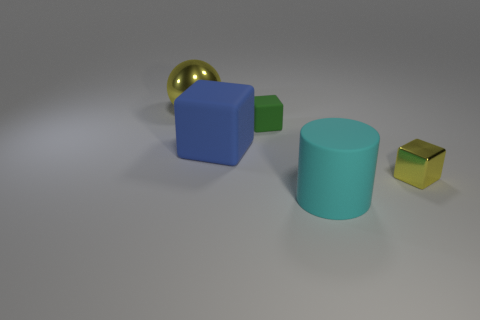Is the color of the large matte cylinder the same as the shiny object that is in front of the large ball?
Keep it short and to the point. No. How many green shiny cylinders are there?
Your answer should be compact. 0. What number of objects are tiny red cylinders or large blocks?
Give a very brief answer. 1. What is the size of the block that is the same color as the big shiny ball?
Provide a short and direct response. Small. Are there any cyan matte cylinders to the right of the tiny green cube?
Give a very brief answer. Yes. Are there more big matte blocks behind the green block than cyan matte things that are in front of the big cyan thing?
Your answer should be compact. No. The green rubber object that is the same shape as the big blue rubber object is what size?
Ensure brevity in your answer.  Small. What number of cubes are either big metallic objects or yellow things?
Ensure brevity in your answer.  1. There is a large ball that is the same color as the tiny shiny block; what is it made of?
Your answer should be very brief. Metal. Is the number of big cyan cylinders right of the cylinder less than the number of large metallic objects to the left of the big blue block?
Provide a short and direct response. Yes. 